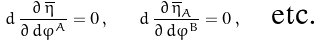<formula> <loc_0><loc_0><loc_500><loc_500>d \, \frac { \partial \, \overline { \eta } } { \partial \, { d } \varphi ^ { A } } = 0 \, , \quad d \, \frac { \partial \, \overline { \eta } _ { A } } { \partial \, { d } \varphi ^ { B } } = 0 \, , \quad \text {etc.}</formula> 